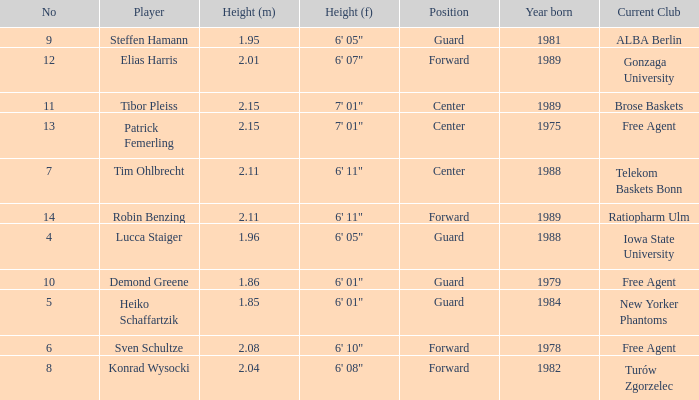Name the height for steffen hamann 6' 05". 